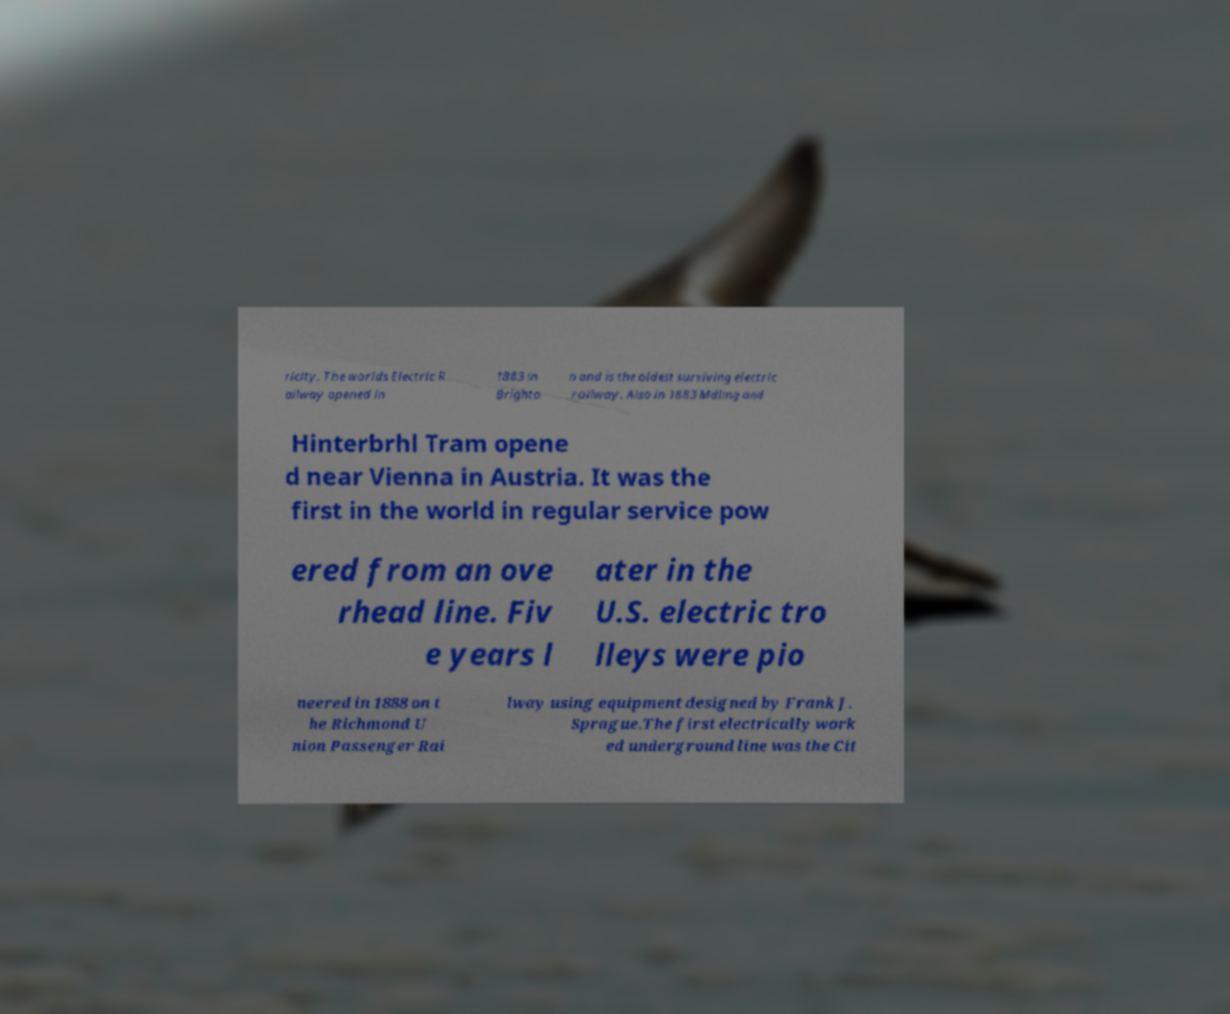For documentation purposes, I need the text within this image transcribed. Could you provide that? ricity. The worlds Electric R ailway opened in 1883 in Brighto n and is the oldest surviving electric railway. Also in 1883 Mdling and Hinterbrhl Tram opene d near Vienna in Austria. It was the first in the world in regular service pow ered from an ove rhead line. Fiv e years l ater in the U.S. electric tro lleys were pio neered in 1888 on t he Richmond U nion Passenger Rai lway using equipment designed by Frank J. Sprague.The first electrically work ed underground line was the Cit 